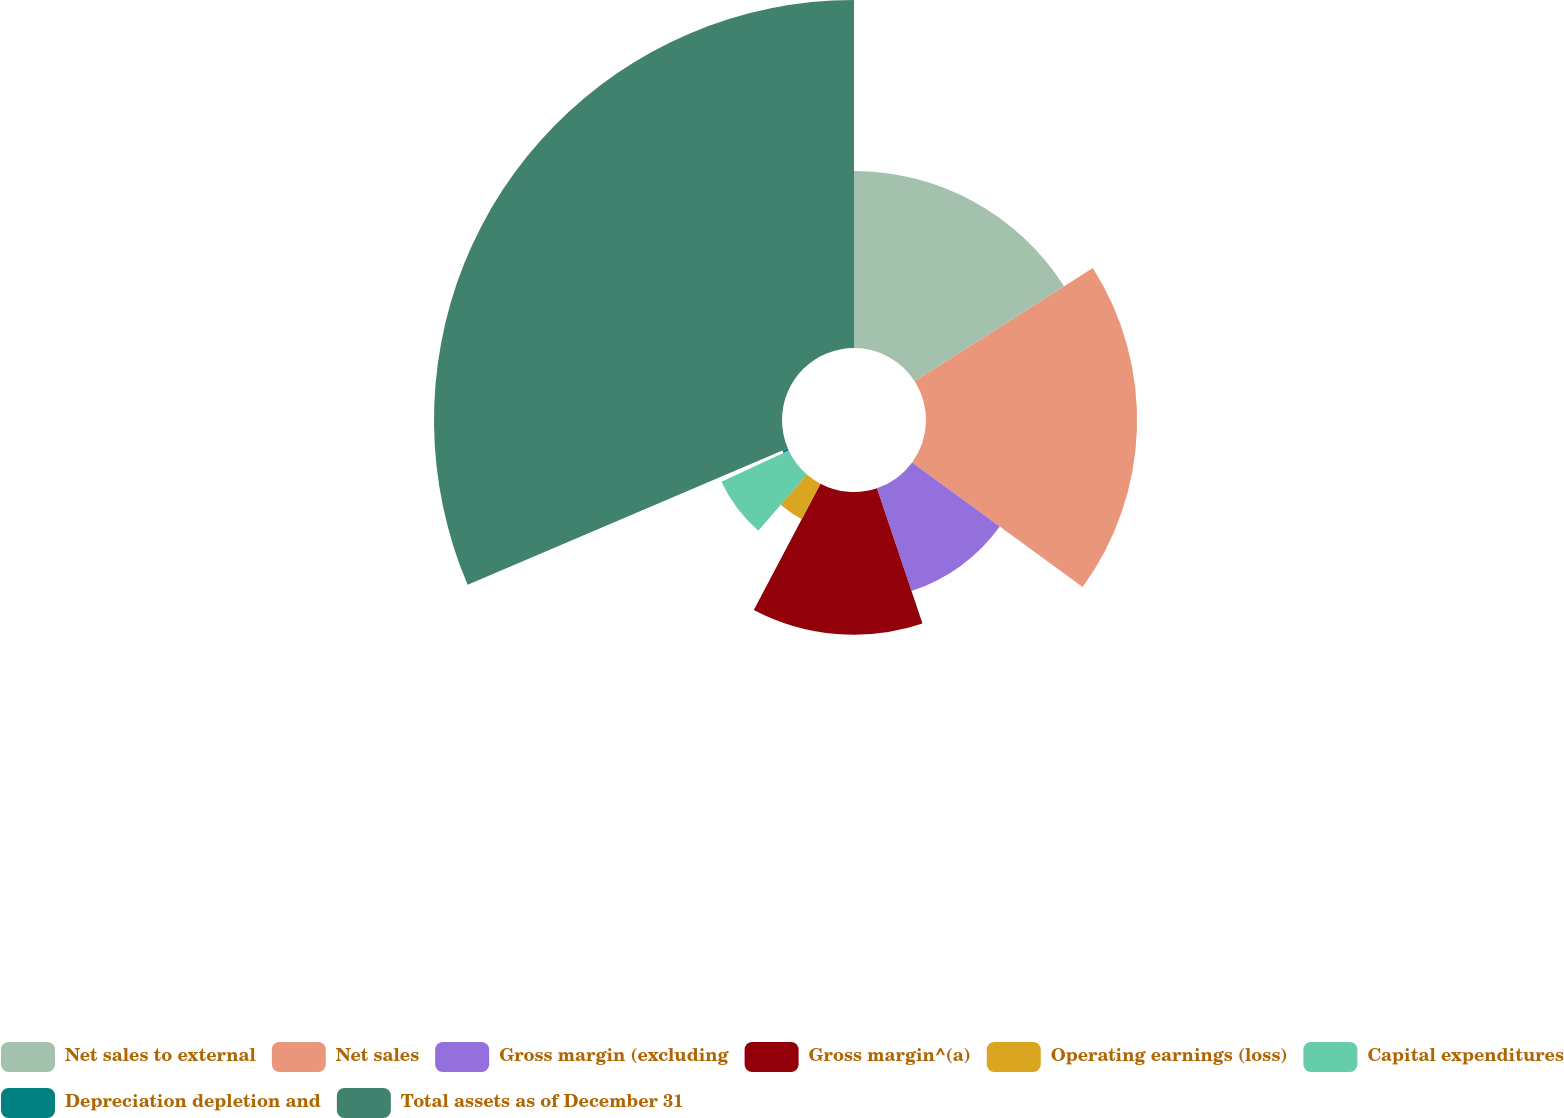Convert chart. <chart><loc_0><loc_0><loc_500><loc_500><pie_chart><fcel>Net sales to external<fcel>Net sales<fcel>Gross margin (excluding<fcel>Gross margin^(a)<fcel>Operating earnings (loss)<fcel>Capital expenditures<fcel>Depreciation depletion and<fcel>Total assets as of December 31<nl><fcel>15.98%<fcel>19.06%<fcel>9.8%<fcel>12.89%<fcel>3.62%<fcel>6.71%<fcel>0.53%<fcel>31.42%<nl></chart> 